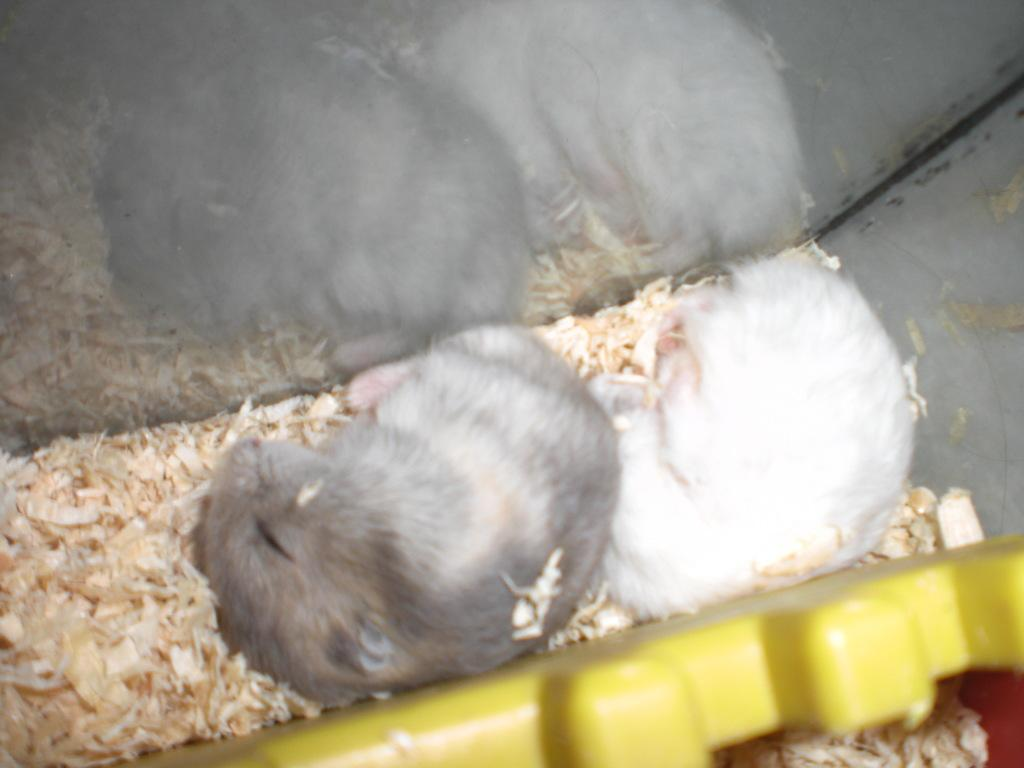What type of animals are present in the image? There are cats in the image. What are the cats doing in the image? The cats are laying over a place. Can you describe the object on the right side of the image? There is a plastic thing on the right side of the image. What type of ticket can be seen in the image? There is no ticket present in the image; it features cats laying over a place and a plastic thing on the right side. Can you solve the riddle that is written on the cats' fur? There is no riddle written on the cats' fur in the image. 